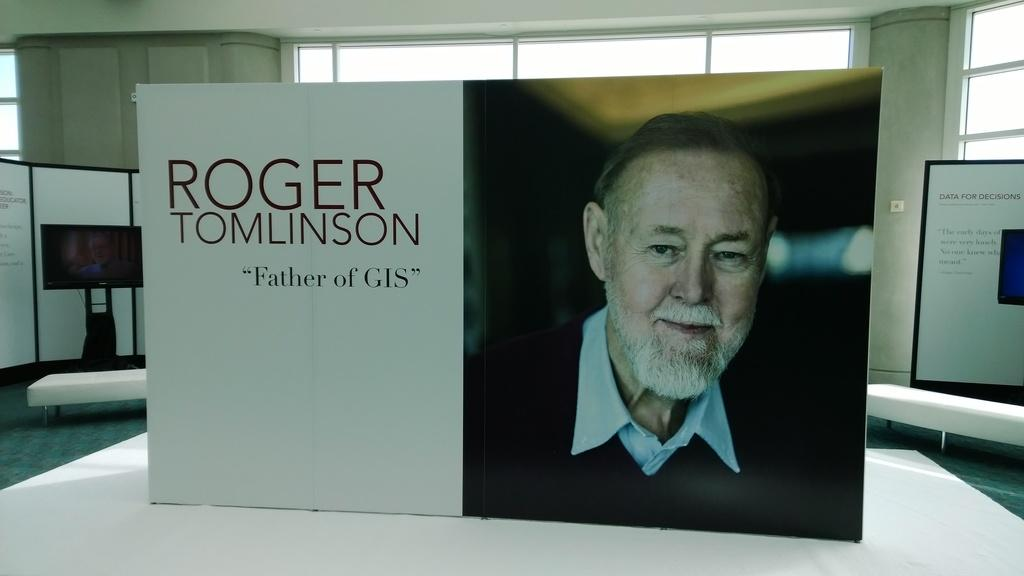What type of decorations are present in the image? There are banners in the image. What electronic device can be seen in the image? There is a television in the image. What architectural feature is visible in the image? There are windows in the image. Who is depicted on one of the banners? A man is smiling on one of the banners. Can you tell me what type of produce is displayed on the windowsill in the image? There is no produce visible in the image; the focus is on the banners, television, and windows. How many owls are present in the image? There are no owls present in the image. 